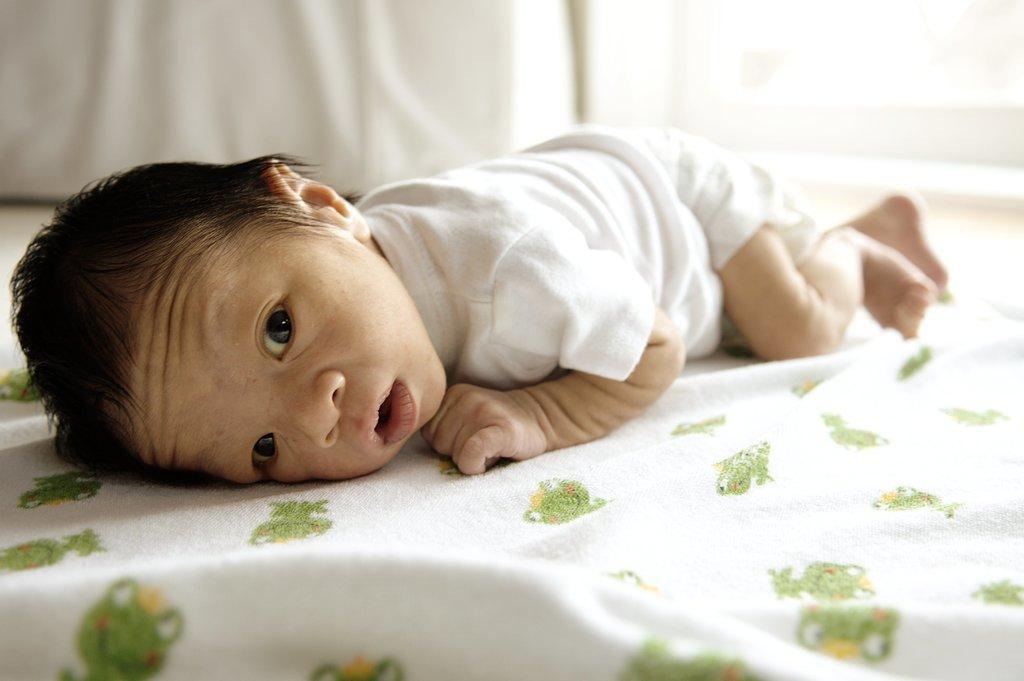In one or two sentences, can you explain what this image depicts? In the picture we can see a small baby sleeping on the bed there is a blanket with green design. 